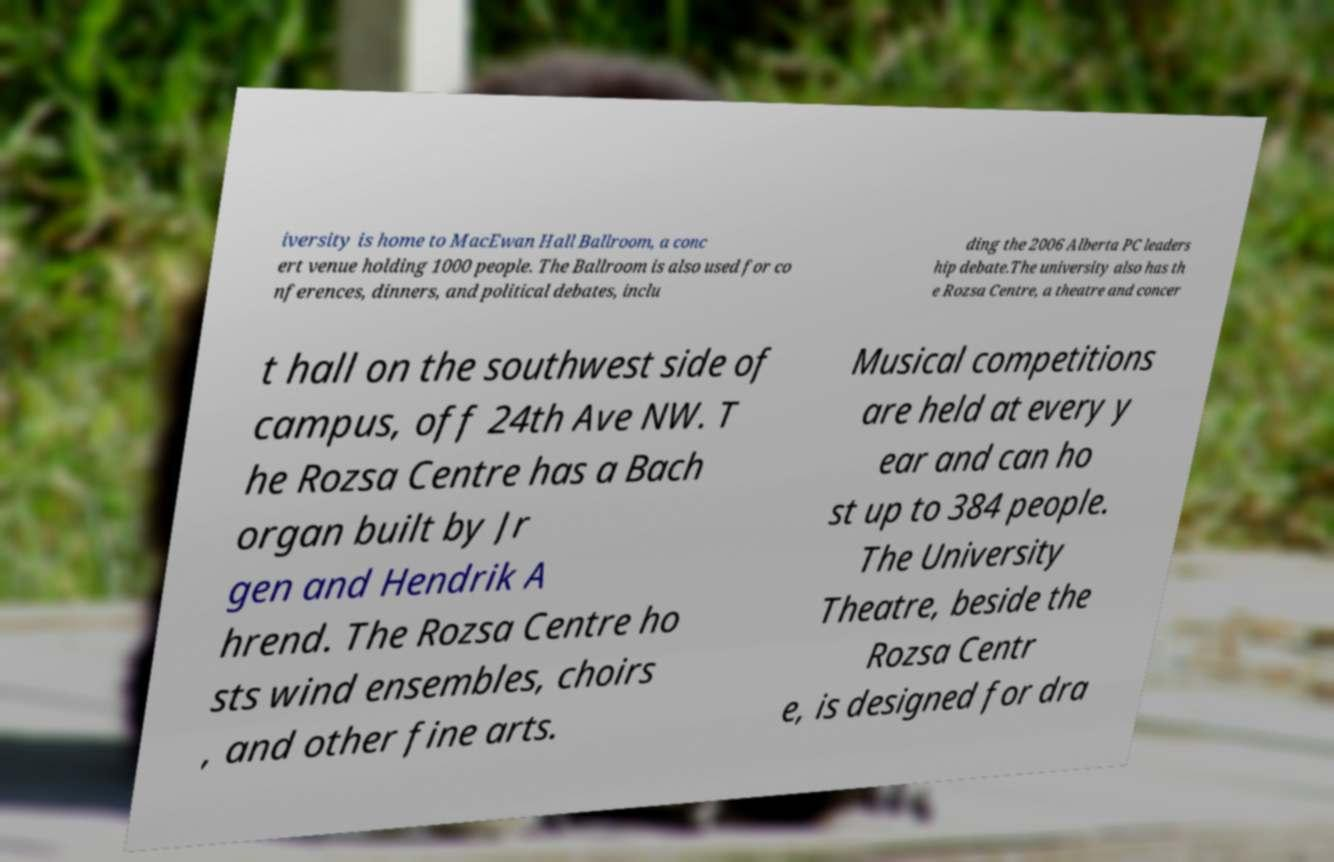Could you assist in decoding the text presented in this image and type it out clearly? iversity is home to MacEwan Hall Ballroom, a conc ert venue holding 1000 people. The Ballroom is also used for co nferences, dinners, and political debates, inclu ding the 2006 Alberta PC leaders hip debate.The university also has th e Rozsa Centre, a theatre and concer t hall on the southwest side of campus, off 24th Ave NW. T he Rozsa Centre has a Bach organ built by Jr gen and Hendrik A hrend. The Rozsa Centre ho sts wind ensembles, choirs , and other fine arts. Musical competitions are held at every y ear and can ho st up to 384 people. The University Theatre, beside the Rozsa Centr e, is designed for dra 